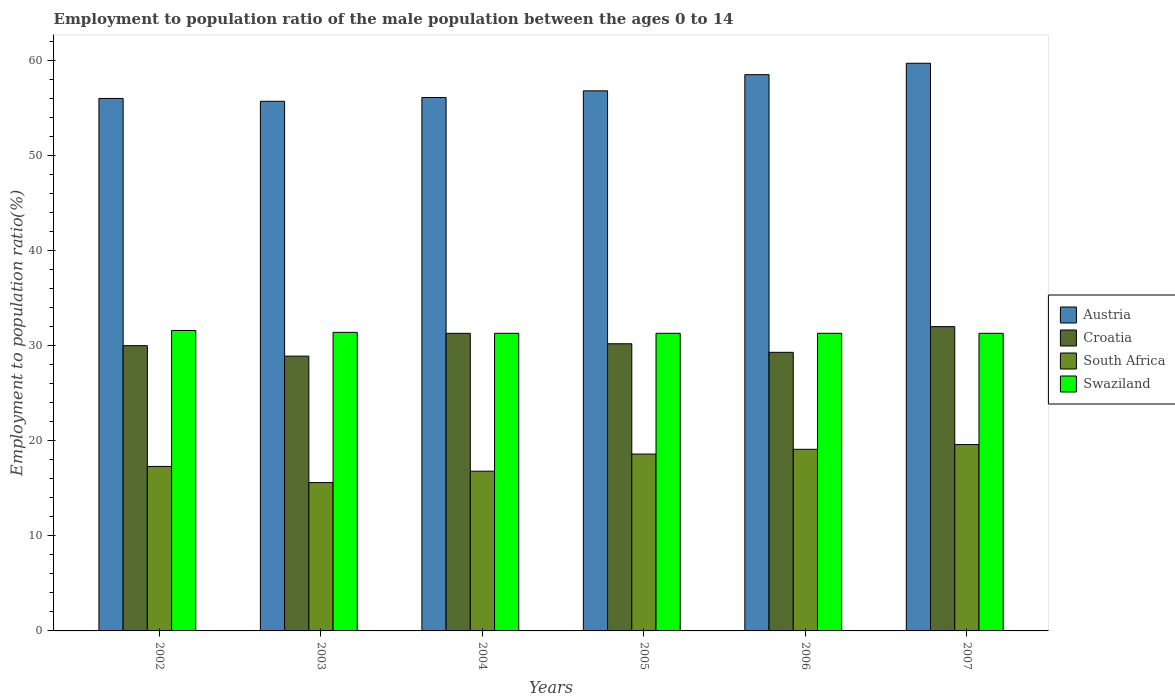How many groups of bars are there?
Ensure brevity in your answer.  6. Are the number of bars per tick equal to the number of legend labels?
Offer a very short reply. Yes. Are the number of bars on each tick of the X-axis equal?
Give a very brief answer. Yes. What is the employment to population ratio in Swaziland in 2003?
Ensure brevity in your answer.  31.4. Across all years, what is the maximum employment to population ratio in Austria?
Offer a very short reply. 59.7. Across all years, what is the minimum employment to population ratio in Austria?
Provide a short and direct response. 55.7. In which year was the employment to population ratio in Swaziland maximum?
Ensure brevity in your answer.  2002. In which year was the employment to population ratio in Croatia minimum?
Ensure brevity in your answer.  2003. What is the total employment to population ratio in Austria in the graph?
Offer a very short reply. 342.8. What is the difference between the employment to population ratio in South Africa in 2003 and that in 2006?
Make the answer very short. -3.5. What is the difference between the employment to population ratio in Croatia in 2007 and the employment to population ratio in South Africa in 2006?
Offer a very short reply. 12.9. What is the average employment to population ratio in South Africa per year?
Make the answer very short. 17.83. In the year 2006, what is the difference between the employment to population ratio in Croatia and employment to population ratio in South Africa?
Your answer should be very brief. 10.2. In how many years, is the employment to population ratio in South Africa greater than 8 %?
Make the answer very short. 6. What is the ratio of the employment to population ratio in Swaziland in 2002 to that in 2007?
Ensure brevity in your answer.  1.01. Is the employment to population ratio in Swaziland in 2002 less than that in 2005?
Your answer should be very brief. No. What is the difference between the highest and the second highest employment to population ratio in Austria?
Provide a succinct answer. 1.2. What is the difference between the highest and the lowest employment to population ratio in Croatia?
Offer a very short reply. 3.1. In how many years, is the employment to population ratio in Swaziland greater than the average employment to population ratio in Swaziland taken over all years?
Offer a very short reply. 2. What does the 4th bar from the left in 2007 represents?
Provide a short and direct response. Swaziland. What does the 1st bar from the right in 2007 represents?
Provide a succinct answer. Swaziland. Is it the case that in every year, the sum of the employment to population ratio in Austria and employment to population ratio in Swaziland is greater than the employment to population ratio in Croatia?
Keep it short and to the point. Yes. How many bars are there?
Provide a succinct answer. 24. How many years are there in the graph?
Your response must be concise. 6. What is the difference between two consecutive major ticks on the Y-axis?
Your answer should be compact. 10. Are the values on the major ticks of Y-axis written in scientific E-notation?
Make the answer very short. No. Does the graph contain any zero values?
Provide a succinct answer. No. Does the graph contain grids?
Keep it short and to the point. No. Where does the legend appear in the graph?
Keep it short and to the point. Center right. How many legend labels are there?
Provide a succinct answer. 4. What is the title of the graph?
Ensure brevity in your answer.  Employment to population ratio of the male population between the ages 0 to 14. What is the label or title of the X-axis?
Your answer should be compact. Years. What is the Employment to population ratio(%) in Austria in 2002?
Provide a succinct answer. 56. What is the Employment to population ratio(%) of Croatia in 2002?
Your answer should be very brief. 30. What is the Employment to population ratio(%) of South Africa in 2002?
Your response must be concise. 17.3. What is the Employment to population ratio(%) of Swaziland in 2002?
Keep it short and to the point. 31.6. What is the Employment to population ratio(%) in Austria in 2003?
Your response must be concise. 55.7. What is the Employment to population ratio(%) of Croatia in 2003?
Provide a succinct answer. 28.9. What is the Employment to population ratio(%) in South Africa in 2003?
Make the answer very short. 15.6. What is the Employment to population ratio(%) in Swaziland in 2003?
Make the answer very short. 31.4. What is the Employment to population ratio(%) in Austria in 2004?
Offer a terse response. 56.1. What is the Employment to population ratio(%) in Croatia in 2004?
Make the answer very short. 31.3. What is the Employment to population ratio(%) of South Africa in 2004?
Your answer should be compact. 16.8. What is the Employment to population ratio(%) in Swaziland in 2004?
Your response must be concise. 31.3. What is the Employment to population ratio(%) in Austria in 2005?
Your answer should be very brief. 56.8. What is the Employment to population ratio(%) in Croatia in 2005?
Your response must be concise. 30.2. What is the Employment to population ratio(%) of South Africa in 2005?
Offer a very short reply. 18.6. What is the Employment to population ratio(%) of Swaziland in 2005?
Ensure brevity in your answer.  31.3. What is the Employment to population ratio(%) in Austria in 2006?
Keep it short and to the point. 58.5. What is the Employment to population ratio(%) in Croatia in 2006?
Provide a short and direct response. 29.3. What is the Employment to population ratio(%) in South Africa in 2006?
Offer a very short reply. 19.1. What is the Employment to population ratio(%) of Swaziland in 2006?
Provide a succinct answer. 31.3. What is the Employment to population ratio(%) of Austria in 2007?
Your answer should be very brief. 59.7. What is the Employment to population ratio(%) in Croatia in 2007?
Ensure brevity in your answer.  32. What is the Employment to population ratio(%) in South Africa in 2007?
Your answer should be compact. 19.6. What is the Employment to population ratio(%) of Swaziland in 2007?
Provide a short and direct response. 31.3. Across all years, what is the maximum Employment to population ratio(%) of Austria?
Offer a very short reply. 59.7. Across all years, what is the maximum Employment to population ratio(%) in Croatia?
Your response must be concise. 32. Across all years, what is the maximum Employment to population ratio(%) in South Africa?
Give a very brief answer. 19.6. Across all years, what is the maximum Employment to population ratio(%) of Swaziland?
Your response must be concise. 31.6. Across all years, what is the minimum Employment to population ratio(%) in Austria?
Provide a succinct answer. 55.7. Across all years, what is the minimum Employment to population ratio(%) in Croatia?
Make the answer very short. 28.9. Across all years, what is the minimum Employment to population ratio(%) in South Africa?
Provide a short and direct response. 15.6. Across all years, what is the minimum Employment to population ratio(%) in Swaziland?
Your response must be concise. 31.3. What is the total Employment to population ratio(%) of Austria in the graph?
Offer a terse response. 342.8. What is the total Employment to population ratio(%) in Croatia in the graph?
Your answer should be very brief. 181.7. What is the total Employment to population ratio(%) of South Africa in the graph?
Give a very brief answer. 107. What is the total Employment to population ratio(%) of Swaziland in the graph?
Keep it short and to the point. 188.2. What is the difference between the Employment to population ratio(%) in Croatia in 2002 and that in 2003?
Your answer should be very brief. 1.1. What is the difference between the Employment to population ratio(%) in South Africa in 2002 and that in 2003?
Your answer should be compact. 1.7. What is the difference between the Employment to population ratio(%) in Austria in 2002 and that in 2004?
Offer a very short reply. -0.1. What is the difference between the Employment to population ratio(%) of Croatia in 2002 and that in 2004?
Make the answer very short. -1.3. What is the difference between the Employment to population ratio(%) in South Africa in 2002 and that in 2004?
Ensure brevity in your answer.  0.5. What is the difference between the Employment to population ratio(%) of South Africa in 2002 and that in 2005?
Provide a short and direct response. -1.3. What is the difference between the Employment to population ratio(%) of Swaziland in 2002 and that in 2005?
Provide a succinct answer. 0.3. What is the difference between the Employment to population ratio(%) of Croatia in 2002 and that in 2006?
Your answer should be compact. 0.7. What is the difference between the Employment to population ratio(%) in Austria in 2002 and that in 2007?
Provide a succinct answer. -3.7. What is the difference between the Employment to population ratio(%) in Swaziland in 2002 and that in 2007?
Your answer should be compact. 0.3. What is the difference between the Employment to population ratio(%) in Austria in 2003 and that in 2004?
Keep it short and to the point. -0.4. What is the difference between the Employment to population ratio(%) in Croatia in 2003 and that in 2004?
Your answer should be very brief. -2.4. What is the difference between the Employment to population ratio(%) in South Africa in 2003 and that in 2004?
Provide a short and direct response. -1.2. What is the difference between the Employment to population ratio(%) in Swaziland in 2003 and that in 2005?
Provide a short and direct response. 0.1. What is the difference between the Employment to population ratio(%) of Croatia in 2003 and that in 2006?
Give a very brief answer. -0.4. What is the difference between the Employment to population ratio(%) of South Africa in 2003 and that in 2006?
Provide a short and direct response. -3.5. What is the difference between the Employment to population ratio(%) of Austria in 2003 and that in 2007?
Give a very brief answer. -4. What is the difference between the Employment to population ratio(%) of Croatia in 2003 and that in 2007?
Keep it short and to the point. -3.1. What is the difference between the Employment to population ratio(%) of Swaziland in 2003 and that in 2007?
Keep it short and to the point. 0.1. What is the difference between the Employment to population ratio(%) of Croatia in 2004 and that in 2005?
Your answer should be compact. 1.1. What is the difference between the Employment to population ratio(%) in South Africa in 2004 and that in 2005?
Give a very brief answer. -1.8. What is the difference between the Employment to population ratio(%) of Swaziland in 2004 and that in 2005?
Your answer should be very brief. 0. What is the difference between the Employment to population ratio(%) of Croatia in 2004 and that in 2006?
Give a very brief answer. 2. What is the difference between the Employment to population ratio(%) in South Africa in 2004 and that in 2006?
Keep it short and to the point. -2.3. What is the difference between the Employment to population ratio(%) of Swaziland in 2004 and that in 2006?
Give a very brief answer. 0. What is the difference between the Employment to population ratio(%) of Austria in 2004 and that in 2007?
Give a very brief answer. -3.6. What is the difference between the Employment to population ratio(%) in Croatia in 2004 and that in 2007?
Ensure brevity in your answer.  -0.7. What is the difference between the Employment to population ratio(%) in South Africa in 2004 and that in 2007?
Offer a terse response. -2.8. What is the difference between the Employment to population ratio(%) of Austria in 2005 and that in 2007?
Offer a terse response. -2.9. What is the difference between the Employment to population ratio(%) in Croatia in 2005 and that in 2007?
Your answer should be compact. -1.8. What is the difference between the Employment to population ratio(%) in South Africa in 2005 and that in 2007?
Make the answer very short. -1. What is the difference between the Employment to population ratio(%) of Swaziland in 2005 and that in 2007?
Offer a very short reply. 0. What is the difference between the Employment to population ratio(%) in Austria in 2006 and that in 2007?
Provide a short and direct response. -1.2. What is the difference between the Employment to population ratio(%) of Croatia in 2006 and that in 2007?
Give a very brief answer. -2.7. What is the difference between the Employment to population ratio(%) in Austria in 2002 and the Employment to population ratio(%) in Croatia in 2003?
Offer a terse response. 27.1. What is the difference between the Employment to population ratio(%) in Austria in 2002 and the Employment to population ratio(%) in South Africa in 2003?
Provide a succinct answer. 40.4. What is the difference between the Employment to population ratio(%) of Austria in 2002 and the Employment to population ratio(%) of Swaziland in 2003?
Ensure brevity in your answer.  24.6. What is the difference between the Employment to population ratio(%) in Croatia in 2002 and the Employment to population ratio(%) in South Africa in 2003?
Your answer should be compact. 14.4. What is the difference between the Employment to population ratio(%) of Croatia in 2002 and the Employment to population ratio(%) of Swaziland in 2003?
Keep it short and to the point. -1.4. What is the difference between the Employment to population ratio(%) in South Africa in 2002 and the Employment to population ratio(%) in Swaziland in 2003?
Make the answer very short. -14.1. What is the difference between the Employment to population ratio(%) of Austria in 2002 and the Employment to population ratio(%) of Croatia in 2004?
Make the answer very short. 24.7. What is the difference between the Employment to population ratio(%) in Austria in 2002 and the Employment to population ratio(%) in South Africa in 2004?
Give a very brief answer. 39.2. What is the difference between the Employment to population ratio(%) of Austria in 2002 and the Employment to population ratio(%) of Swaziland in 2004?
Keep it short and to the point. 24.7. What is the difference between the Employment to population ratio(%) in Croatia in 2002 and the Employment to population ratio(%) in South Africa in 2004?
Offer a very short reply. 13.2. What is the difference between the Employment to population ratio(%) of Croatia in 2002 and the Employment to population ratio(%) of Swaziland in 2004?
Provide a short and direct response. -1.3. What is the difference between the Employment to population ratio(%) of South Africa in 2002 and the Employment to population ratio(%) of Swaziland in 2004?
Your response must be concise. -14. What is the difference between the Employment to population ratio(%) of Austria in 2002 and the Employment to population ratio(%) of Croatia in 2005?
Your answer should be compact. 25.8. What is the difference between the Employment to population ratio(%) of Austria in 2002 and the Employment to population ratio(%) of South Africa in 2005?
Your answer should be very brief. 37.4. What is the difference between the Employment to population ratio(%) of Austria in 2002 and the Employment to population ratio(%) of Swaziland in 2005?
Your answer should be compact. 24.7. What is the difference between the Employment to population ratio(%) in Croatia in 2002 and the Employment to population ratio(%) in Swaziland in 2005?
Your answer should be very brief. -1.3. What is the difference between the Employment to population ratio(%) of South Africa in 2002 and the Employment to population ratio(%) of Swaziland in 2005?
Give a very brief answer. -14. What is the difference between the Employment to population ratio(%) in Austria in 2002 and the Employment to population ratio(%) in Croatia in 2006?
Make the answer very short. 26.7. What is the difference between the Employment to population ratio(%) of Austria in 2002 and the Employment to population ratio(%) of South Africa in 2006?
Give a very brief answer. 36.9. What is the difference between the Employment to population ratio(%) in Austria in 2002 and the Employment to population ratio(%) in Swaziland in 2006?
Give a very brief answer. 24.7. What is the difference between the Employment to population ratio(%) of Croatia in 2002 and the Employment to population ratio(%) of South Africa in 2006?
Give a very brief answer. 10.9. What is the difference between the Employment to population ratio(%) of South Africa in 2002 and the Employment to population ratio(%) of Swaziland in 2006?
Provide a succinct answer. -14. What is the difference between the Employment to population ratio(%) of Austria in 2002 and the Employment to population ratio(%) of Croatia in 2007?
Your answer should be very brief. 24. What is the difference between the Employment to population ratio(%) of Austria in 2002 and the Employment to population ratio(%) of South Africa in 2007?
Give a very brief answer. 36.4. What is the difference between the Employment to population ratio(%) in Austria in 2002 and the Employment to population ratio(%) in Swaziland in 2007?
Make the answer very short. 24.7. What is the difference between the Employment to population ratio(%) in Croatia in 2002 and the Employment to population ratio(%) in South Africa in 2007?
Offer a terse response. 10.4. What is the difference between the Employment to population ratio(%) in Croatia in 2002 and the Employment to population ratio(%) in Swaziland in 2007?
Offer a terse response. -1.3. What is the difference between the Employment to population ratio(%) of Austria in 2003 and the Employment to population ratio(%) of Croatia in 2004?
Keep it short and to the point. 24.4. What is the difference between the Employment to population ratio(%) of Austria in 2003 and the Employment to population ratio(%) of South Africa in 2004?
Give a very brief answer. 38.9. What is the difference between the Employment to population ratio(%) of Austria in 2003 and the Employment to population ratio(%) of Swaziland in 2004?
Make the answer very short. 24.4. What is the difference between the Employment to population ratio(%) of Croatia in 2003 and the Employment to population ratio(%) of South Africa in 2004?
Your answer should be compact. 12.1. What is the difference between the Employment to population ratio(%) in Croatia in 2003 and the Employment to population ratio(%) in Swaziland in 2004?
Provide a succinct answer. -2.4. What is the difference between the Employment to population ratio(%) in South Africa in 2003 and the Employment to population ratio(%) in Swaziland in 2004?
Your answer should be compact. -15.7. What is the difference between the Employment to population ratio(%) in Austria in 2003 and the Employment to population ratio(%) in Croatia in 2005?
Keep it short and to the point. 25.5. What is the difference between the Employment to population ratio(%) of Austria in 2003 and the Employment to population ratio(%) of South Africa in 2005?
Give a very brief answer. 37.1. What is the difference between the Employment to population ratio(%) in Austria in 2003 and the Employment to population ratio(%) in Swaziland in 2005?
Keep it short and to the point. 24.4. What is the difference between the Employment to population ratio(%) of South Africa in 2003 and the Employment to population ratio(%) of Swaziland in 2005?
Your response must be concise. -15.7. What is the difference between the Employment to population ratio(%) of Austria in 2003 and the Employment to population ratio(%) of Croatia in 2006?
Provide a short and direct response. 26.4. What is the difference between the Employment to population ratio(%) of Austria in 2003 and the Employment to population ratio(%) of South Africa in 2006?
Provide a succinct answer. 36.6. What is the difference between the Employment to population ratio(%) in Austria in 2003 and the Employment to population ratio(%) in Swaziland in 2006?
Give a very brief answer. 24.4. What is the difference between the Employment to population ratio(%) in Croatia in 2003 and the Employment to population ratio(%) in South Africa in 2006?
Offer a terse response. 9.8. What is the difference between the Employment to population ratio(%) in South Africa in 2003 and the Employment to population ratio(%) in Swaziland in 2006?
Your response must be concise. -15.7. What is the difference between the Employment to population ratio(%) in Austria in 2003 and the Employment to population ratio(%) in Croatia in 2007?
Offer a very short reply. 23.7. What is the difference between the Employment to population ratio(%) of Austria in 2003 and the Employment to population ratio(%) of South Africa in 2007?
Give a very brief answer. 36.1. What is the difference between the Employment to population ratio(%) in Austria in 2003 and the Employment to population ratio(%) in Swaziland in 2007?
Your answer should be very brief. 24.4. What is the difference between the Employment to population ratio(%) of Croatia in 2003 and the Employment to population ratio(%) of Swaziland in 2007?
Your answer should be compact. -2.4. What is the difference between the Employment to population ratio(%) in South Africa in 2003 and the Employment to population ratio(%) in Swaziland in 2007?
Your answer should be compact. -15.7. What is the difference between the Employment to population ratio(%) of Austria in 2004 and the Employment to population ratio(%) of Croatia in 2005?
Ensure brevity in your answer.  25.9. What is the difference between the Employment to population ratio(%) in Austria in 2004 and the Employment to population ratio(%) in South Africa in 2005?
Offer a terse response. 37.5. What is the difference between the Employment to population ratio(%) of Austria in 2004 and the Employment to population ratio(%) of Swaziland in 2005?
Your answer should be very brief. 24.8. What is the difference between the Employment to population ratio(%) of Croatia in 2004 and the Employment to population ratio(%) of South Africa in 2005?
Ensure brevity in your answer.  12.7. What is the difference between the Employment to population ratio(%) in South Africa in 2004 and the Employment to population ratio(%) in Swaziland in 2005?
Provide a short and direct response. -14.5. What is the difference between the Employment to population ratio(%) of Austria in 2004 and the Employment to population ratio(%) of Croatia in 2006?
Offer a terse response. 26.8. What is the difference between the Employment to population ratio(%) in Austria in 2004 and the Employment to population ratio(%) in South Africa in 2006?
Keep it short and to the point. 37. What is the difference between the Employment to population ratio(%) of Austria in 2004 and the Employment to population ratio(%) of Swaziland in 2006?
Keep it short and to the point. 24.8. What is the difference between the Employment to population ratio(%) of Croatia in 2004 and the Employment to population ratio(%) of South Africa in 2006?
Ensure brevity in your answer.  12.2. What is the difference between the Employment to population ratio(%) in Croatia in 2004 and the Employment to population ratio(%) in Swaziland in 2006?
Offer a terse response. 0. What is the difference between the Employment to population ratio(%) in South Africa in 2004 and the Employment to population ratio(%) in Swaziland in 2006?
Provide a succinct answer. -14.5. What is the difference between the Employment to population ratio(%) of Austria in 2004 and the Employment to population ratio(%) of Croatia in 2007?
Offer a very short reply. 24.1. What is the difference between the Employment to population ratio(%) in Austria in 2004 and the Employment to population ratio(%) in South Africa in 2007?
Keep it short and to the point. 36.5. What is the difference between the Employment to population ratio(%) in Austria in 2004 and the Employment to population ratio(%) in Swaziland in 2007?
Give a very brief answer. 24.8. What is the difference between the Employment to population ratio(%) in Croatia in 2004 and the Employment to population ratio(%) in Swaziland in 2007?
Your answer should be very brief. 0. What is the difference between the Employment to population ratio(%) of South Africa in 2004 and the Employment to population ratio(%) of Swaziland in 2007?
Make the answer very short. -14.5. What is the difference between the Employment to population ratio(%) in Austria in 2005 and the Employment to population ratio(%) in South Africa in 2006?
Your response must be concise. 37.7. What is the difference between the Employment to population ratio(%) in Austria in 2005 and the Employment to population ratio(%) in Swaziland in 2006?
Make the answer very short. 25.5. What is the difference between the Employment to population ratio(%) of Austria in 2005 and the Employment to population ratio(%) of Croatia in 2007?
Make the answer very short. 24.8. What is the difference between the Employment to population ratio(%) of Austria in 2005 and the Employment to population ratio(%) of South Africa in 2007?
Make the answer very short. 37.2. What is the difference between the Employment to population ratio(%) in Austria in 2005 and the Employment to population ratio(%) in Swaziland in 2007?
Offer a very short reply. 25.5. What is the difference between the Employment to population ratio(%) of Croatia in 2005 and the Employment to population ratio(%) of South Africa in 2007?
Your answer should be very brief. 10.6. What is the difference between the Employment to population ratio(%) of Austria in 2006 and the Employment to population ratio(%) of South Africa in 2007?
Your answer should be compact. 38.9. What is the difference between the Employment to population ratio(%) in Austria in 2006 and the Employment to population ratio(%) in Swaziland in 2007?
Provide a succinct answer. 27.2. What is the difference between the Employment to population ratio(%) in Croatia in 2006 and the Employment to population ratio(%) in Swaziland in 2007?
Ensure brevity in your answer.  -2. What is the average Employment to population ratio(%) of Austria per year?
Your response must be concise. 57.13. What is the average Employment to population ratio(%) in Croatia per year?
Offer a very short reply. 30.28. What is the average Employment to population ratio(%) of South Africa per year?
Make the answer very short. 17.83. What is the average Employment to population ratio(%) of Swaziland per year?
Provide a short and direct response. 31.37. In the year 2002, what is the difference between the Employment to population ratio(%) in Austria and Employment to population ratio(%) in Croatia?
Your response must be concise. 26. In the year 2002, what is the difference between the Employment to population ratio(%) in Austria and Employment to population ratio(%) in South Africa?
Provide a succinct answer. 38.7. In the year 2002, what is the difference between the Employment to population ratio(%) in Austria and Employment to population ratio(%) in Swaziland?
Make the answer very short. 24.4. In the year 2002, what is the difference between the Employment to population ratio(%) in Croatia and Employment to population ratio(%) in South Africa?
Make the answer very short. 12.7. In the year 2002, what is the difference between the Employment to population ratio(%) of Croatia and Employment to population ratio(%) of Swaziland?
Ensure brevity in your answer.  -1.6. In the year 2002, what is the difference between the Employment to population ratio(%) in South Africa and Employment to population ratio(%) in Swaziland?
Your answer should be very brief. -14.3. In the year 2003, what is the difference between the Employment to population ratio(%) of Austria and Employment to population ratio(%) of Croatia?
Your answer should be very brief. 26.8. In the year 2003, what is the difference between the Employment to population ratio(%) of Austria and Employment to population ratio(%) of South Africa?
Ensure brevity in your answer.  40.1. In the year 2003, what is the difference between the Employment to population ratio(%) in Austria and Employment to population ratio(%) in Swaziland?
Provide a succinct answer. 24.3. In the year 2003, what is the difference between the Employment to population ratio(%) in Croatia and Employment to population ratio(%) in South Africa?
Keep it short and to the point. 13.3. In the year 2003, what is the difference between the Employment to population ratio(%) of South Africa and Employment to population ratio(%) of Swaziland?
Your response must be concise. -15.8. In the year 2004, what is the difference between the Employment to population ratio(%) of Austria and Employment to population ratio(%) of Croatia?
Provide a short and direct response. 24.8. In the year 2004, what is the difference between the Employment to population ratio(%) in Austria and Employment to population ratio(%) in South Africa?
Ensure brevity in your answer.  39.3. In the year 2004, what is the difference between the Employment to population ratio(%) of Austria and Employment to population ratio(%) of Swaziland?
Offer a terse response. 24.8. In the year 2004, what is the difference between the Employment to population ratio(%) in Croatia and Employment to population ratio(%) in South Africa?
Make the answer very short. 14.5. In the year 2004, what is the difference between the Employment to population ratio(%) of Croatia and Employment to population ratio(%) of Swaziland?
Your answer should be compact. 0. In the year 2004, what is the difference between the Employment to population ratio(%) in South Africa and Employment to population ratio(%) in Swaziland?
Provide a succinct answer. -14.5. In the year 2005, what is the difference between the Employment to population ratio(%) of Austria and Employment to population ratio(%) of Croatia?
Make the answer very short. 26.6. In the year 2005, what is the difference between the Employment to population ratio(%) in Austria and Employment to population ratio(%) in South Africa?
Your response must be concise. 38.2. In the year 2005, what is the difference between the Employment to population ratio(%) of Croatia and Employment to population ratio(%) of Swaziland?
Your response must be concise. -1.1. In the year 2006, what is the difference between the Employment to population ratio(%) in Austria and Employment to population ratio(%) in Croatia?
Provide a succinct answer. 29.2. In the year 2006, what is the difference between the Employment to population ratio(%) of Austria and Employment to population ratio(%) of South Africa?
Provide a short and direct response. 39.4. In the year 2006, what is the difference between the Employment to population ratio(%) of Austria and Employment to population ratio(%) of Swaziland?
Provide a succinct answer. 27.2. In the year 2006, what is the difference between the Employment to population ratio(%) in Croatia and Employment to population ratio(%) in South Africa?
Offer a very short reply. 10.2. In the year 2006, what is the difference between the Employment to population ratio(%) in South Africa and Employment to population ratio(%) in Swaziland?
Keep it short and to the point. -12.2. In the year 2007, what is the difference between the Employment to population ratio(%) of Austria and Employment to population ratio(%) of Croatia?
Offer a very short reply. 27.7. In the year 2007, what is the difference between the Employment to population ratio(%) of Austria and Employment to population ratio(%) of South Africa?
Make the answer very short. 40.1. In the year 2007, what is the difference between the Employment to population ratio(%) in Austria and Employment to population ratio(%) in Swaziland?
Your response must be concise. 28.4. In the year 2007, what is the difference between the Employment to population ratio(%) of Croatia and Employment to population ratio(%) of South Africa?
Your response must be concise. 12.4. What is the ratio of the Employment to population ratio(%) of Austria in 2002 to that in 2003?
Provide a short and direct response. 1.01. What is the ratio of the Employment to population ratio(%) in Croatia in 2002 to that in 2003?
Your answer should be very brief. 1.04. What is the ratio of the Employment to population ratio(%) in South Africa in 2002 to that in 2003?
Your answer should be very brief. 1.11. What is the ratio of the Employment to population ratio(%) of Swaziland in 2002 to that in 2003?
Offer a terse response. 1.01. What is the ratio of the Employment to population ratio(%) of Croatia in 2002 to that in 2004?
Give a very brief answer. 0.96. What is the ratio of the Employment to population ratio(%) of South Africa in 2002 to that in 2004?
Make the answer very short. 1.03. What is the ratio of the Employment to population ratio(%) of Swaziland in 2002 to that in 2004?
Make the answer very short. 1.01. What is the ratio of the Employment to population ratio(%) in Austria in 2002 to that in 2005?
Your answer should be compact. 0.99. What is the ratio of the Employment to population ratio(%) of Croatia in 2002 to that in 2005?
Offer a terse response. 0.99. What is the ratio of the Employment to population ratio(%) of South Africa in 2002 to that in 2005?
Your response must be concise. 0.93. What is the ratio of the Employment to population ratio(%) of Swaziland in 2002 to that in 2005?
Provide a short and direct response. 1.01. What is the ratio of the Employment to population ratio(%) of Austria in 2002 to that in 2006?
Keep it short and to the point. 0.96. What is the ratio of the Employment to population ratio(%) of Croatia in 2002 to that in 2006?
Give a very brief answer. 1.02. What is the ratio of the Employment to population ratio(%) of South Africa in 2002 to that in 2006?
Your answer should be very brief. 0.91. What is the ratio of the Employment to population ratio(%) in Swaziland in 2002 to that in 2006?
Ensure brevity in your answer.  1.01. What is the ratio of the Employment to population ratio(%) in Austria in 2002 to that in 2007?
Your response must be concise. 0.94. What is the ratio of the Employment to population ratio(%) in Croatia in 2002 to that in 2007?
Make the answer very short. 0.94. What is the ratio of the Employment to population ratio(%) of South Africa in 2002 to that in 2007?
Keep it short and to the point. 0.88. What is the ratio of the Employment to population ratio(%) of Swaziland in 2002 to that in 2007?
Your answer should be very brief. 1.01. What is the ratio of the Employment to population ratio(%) of Croatia in 2003 to that in 2004?
Ensure brevity in your answer.  0.92. What is the ratio of the Employment to population ratio(%) in South Africa in 2003 to that in 2004?
Provide a succinct answer. 0.93. What is the ratio of the Employment to population ratio(%) in Austria in 2003 to that in 2005?
Offer a terse response. 0.98. What is the ratio of the Employment to population ratio(%) in Croatia in 2003 to that in 2005?
Your answer should be very brief. 0.96. What is the ratio of the Employment to population ratio(%) of South Africa in 2003 to that in 2005?
Provide a succinct answer. 0.84. What is the ratio of the Employment to population ratio(%) in Swaziland in 2003 to that in 2005?
Provide a succinct answer. 1. What is the ratio of the Employment to population ratio(%) in Austria in 2003 to that in 2006?
Your answer should be very brief. 0.95. What is the ratio of the Employment to population ratio(%) in Croatia in 2003 to that in 2006?
Your answer should be compact. 0.99. What is the ratio of the Employment to population ratio(%) of South Africa in 2003 to that in 2006?
Your answer should be compact. 0.82. What is the ratio of the Employment to population ratio(%) of Swaziland in 2003 to that in 2006?
Your answer should be very brief. 1. What is the ratio of the Employment to population ratio(%) of Austria in 2003 to that in 2007?
Give a very brief answer. 0.93. What is the ratio of the Employment to population ratio(%) of Croatia in 2003 to that in 2007?
Provide a succinct answer. 0.9. What is the ratio of the Employment to population ratio(%) in South Africa in 2003 to that in 2007?
Give a very brief answer. 0.8. What is the ratio of the Employment to population ratio(%) of Croatia in 2004 to that in 2005?
Offer a very short reply. 1.04. What is the ratio of the Employment to population ratio(%) in South Africa in 2004 to that in 2005?
Your answer should be compact. 0.9. What is the ratio of the Employment to population ratio(%) in Swaziland in 2004 to that in 2005?
Give a very brief answer. 1. What is the ratio of the Employment to population ratio(%) of Austria in 2004 to that in 2006?
Give a very brief answer. 0.96. What is the ratio of the Employment to population ratio(%) in Croatia in 2004 to that in 2006?
Your answer should be very brief. 1.07. What is the ratio of the Employment to population ratio(%) of South Africa in 2004 to that in 2006?
Offer a terse response. 0.88. What is the ratio of the Employment to population ratio(%) in Swaziland in 2004 to that in 2006?
Your response must be concise. 1. What is the ratio of the Employment to population ratio(%) in Austria in 2004 to that in 2007?
Your response must be concise. 0.94. What is the ratio of the Employment to population ratio(%) in Croatia in 2004 to that in 2007?
Your response must be concise. 0.98. What is the ratio of the Employment to population ratio(%) of Swaziland in 2004 to that in 2007?
Provide a short and direct response. 1. What is the ratio of the Employment to population ratio(%) of Austria in 2005 to that in 2006?
Provide a short and direct response. 0.97. What is the ratio of the Employment to population ratio(%) in Croatia in 2005 to that in 2006?
Your answer should be very brief. 1.03. What is the ratio of the Employment to population ratio(%) of South Africa in 2005 to that in 2006?
Your answer should be very brief. 0.97. What is the ratio of the Employment to population ratio(%) of Swaziland in 2005 to that in 2006?
Offer a very short reply. 1. What is the ratio of the Employment to population ratio(%) in Austria in 2005 to that in 2007?
Make the answer very short. 0.95. What is the ratio of the Employment to population ratio(%) of Croatia in 2005 to that in 2007?
Provide a short and direct response. 0.94. What is the ratio of the Employment to population ratio(%) of South Africa in 2005 to that in 2007?
Give a very brief answer. 0.95. What is the ratio of the Employment to population ratio(%) in Austria in 2006 to that in 2007?
Offer a very short reply. 0.98. What is the ratio of the Employment to population ratio(%) of Croatia in 2006 to that in 2007?
Offer a terse response. 0.92. What is the ratio of the Employment to population ratio(%) of South Africa in 2006 to that in 2007?
Offer a very short reply. 0.97. What is the ratio of the Employment to population ratio(%) of Swaziland in 2006 to that in 2007?
Your response must be concise. 1. What is the difference between the highest and the second highest Employment to population ratio(%) of Austria?
Ensure brevity in your answer.  1.2. What is the difference between the highest and the lowest Employment to population ratio(%) in Swaziland?
Provide a short and direct response. 0.3. 